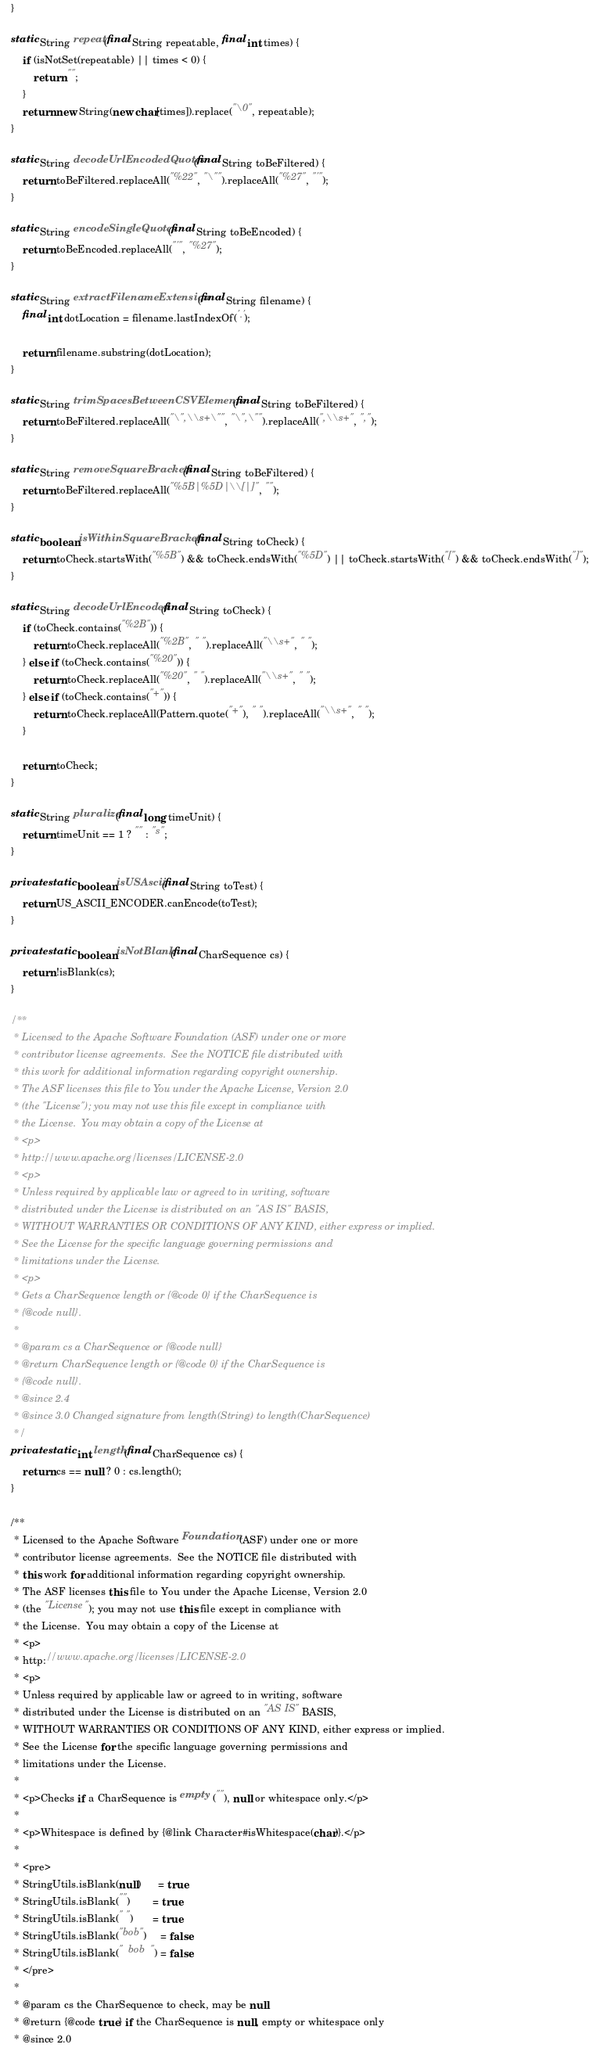Convert code to text. <code><loc_0><loc_0><loc_500><loc_500><_Java_>    }

    static String repeat(final String repeatable, final int times) {
        if (isNotSet(repeatable) || times < 0) {
            return "";
        }
        return new String(new char[times]).replace("\0", repeatable);
    }

    static String decodeUrlEncodedQuotes(final String toBeFiltered) {
        return toBeFiltered.replaceAll("%22", "\"").replaceAll("%27", "'");
    }

    static String encodeSingleQuotes(final String toBeEncoded) {
        return toBeEncoded.replaceAll("'", "%27");
    }

    static String extractFilenameExtension(final String filename) {
        final int dotLocation = filename.lastIndexOf('.');

        return filename.substring(dotLocation);
    }

    static String trimSpacesBetweenCSVElements(final String toBeFiltered) {
        return toBeFiltered.replaceAll("\",\\s+\"", "\",\"").replaceAll(",\\s+", ",");
    }

    static String removeSquareBrackets(final String toBeFiltered) {
        return toBeFiltered.replaceAll("%5B|%5D|\\[|]", "");
    }

    static boolean isWithinSquareBrackets(final String toCheck) {
        return toCheck.startsWith("%5B") && toCheck.endsWith("%5D") || toCheck.startsWith("[") && toCheck.endsWith("]");
    }

    static String decodeUrlEncoded(final String toCheck) {
        if (toCheck.contains("%2B")) {
            return toCheck.replaceAll("%2B", " ").replaceAll("\\s+", " ");
        } else if (toCheck.contains("%20")) {
            return toCheck.replaceAll("%20", " ").replaceAll("\\s+", " ");
        } else if (toCheck.contains("+")) {
            return toCheck.replaceAll(Pattern.quote("+"), " ").replaceAll("\\s+", " ");
        }

        return toCheck;
    }

    static String pluralize(final long timeUnit) {
        return timeUnit == 1 ? "" : "s";
    }

    private static boolean isUSAscii(final String toTest) {
        return US_ASCII_ENCODER.canEncode(toTest);
    }

    private static boolean isNotBlank(final CharSequence cs) {
        return !isBlank(cs);
    }

    /**
     * Licensed to the Apache Software Foundation (ASF) under one or more
     * contributor license agreements.  See the NOTICE file distributed with
     * this work for additional information regarding copyright ownership.
     * The ASF licenses this file to You under the Apache License, Version 2.0
     * (the "License"); you may not use this file except in compliance with
     * the License.  You may obtain a copy of the License at
     * <p>
     * http://www.apache.org/licenses/LICENSE-2.0
     * <p>
     * Unless required by applicable law or agreed to in writing, software
     * distributed under the License is distributed on an "AS IS" BASIS,
     * WITHOUT WARRANTIES OR CONDITIONS OF ANY KIND, either express or implied.
     * See the License for the specific language governing permissions and
     * limitations under the License.
     * <p>
     * Gets a CharSequence length or {@code 0} if the CharSequence is
     * {@code null}.
     *
     * @param cs a CharSequence or {@code null}
     * @return CharSequence length or {@code 0} if the CharSequence is
     * {@code null}.
     * @since 2.4
     * @since 3.0 Changed signature from length(String) to length(CharSequence)
     */
    private static int length(final CharSequence cs) {
        return cs == null ? 0 : cs.length();
    }

    /**
     * Licensed to the Apache Software Foundation (ASF) under one or more
     * contributor license agreements.  See the NOTICE file distributed with
     * this work for additional information regarding copyright ownership.
     * The ASF licenses this file to You under the Apache License, Version 2.0
     * (the "License"); you may not use this file except in compliance with
     * the License.  You may obtain a copy of the License at
     * <p>
     * http://www.apache.org/licenses/LICENSE-2.0
     * <p>
     * Unless required by applicable law or agreed to in writing, software
     * distributed under the License is distributed on an "AS IS" BASIS,
     * WITHOUT WARRANTIES OR CONDITIONS OF ANY KIND, either express or implied.
     * See the License for the specific language governing permissions and
     * limitations under the License.
     *
     * <p>Checks if a CharSequence is empty (""), null or whitespace only.</p>
     *
     * <p>Whitespace is defined by {@link Character#isWhitespace(char)}.</p>
     *
     * <pre>
     * StringUtils.isBlank(null)      = true
     * StringUtils.isBlank("")        = true
     * StringUtils.isBlank(" ")       = true
     * StringUtils.isBlank("bob")     = false
     * StringUtils.isBlank("  bob  ") = false
     * </pre>
     *
     * @param cs the CharSequence to check, may be null
     * @return {@code true} if the CharSequence is null, empty or whitespace only
     * @since 2.0</code> 